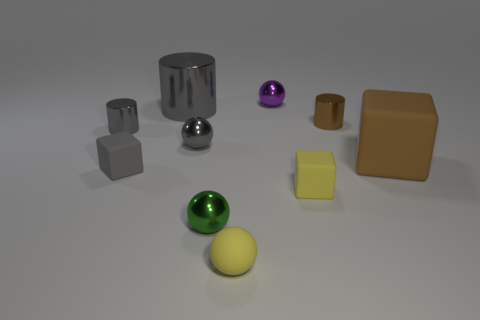There is a matte block that is the same color as the large metal cylinder; what size is it?
Your answer should be very brief. Small. There is a purple thing that is on the left side of the tiny yellow block; what is it made of?
Make the answer very short. Metal. Is the shape of the tiny yellow rubber thing to the left of the small purple metallic ball the same as the small gray thing that is on the right side of the big gray cylinder?
Provide a succinct answer. Yes. There is a cylinder that is the same color as the big cube; what is it made of?
Keep it short and to the point. Metal. Is there a large red rubber block?
Your response must be concise. No. What material is the small gray object that is the same shape as the green metallic thing?
Offer a very short reply. Metal. Are there any small cylinders on the left side of the tiny purple thing?
Make the answer very short. Yes. Are the large cylinder that is behind the yellow matte cube and the small gray cube made of the same material?
Offer a terse response. No. Is there a small metal sphere that has the same color as the big matte thing?
Offer a very short reply. No. What shape is the tiny green shiny thing?
Offer a very short reply. Sphere. 